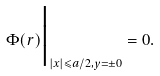Convert formula to latex. <formula><loc_0><loc_0><loc_500><loc_500>\Phi ( { r } ) \Big | _ { | x | \leqslant a / 2 , y = \pm 0 } = 0 .</formula> 